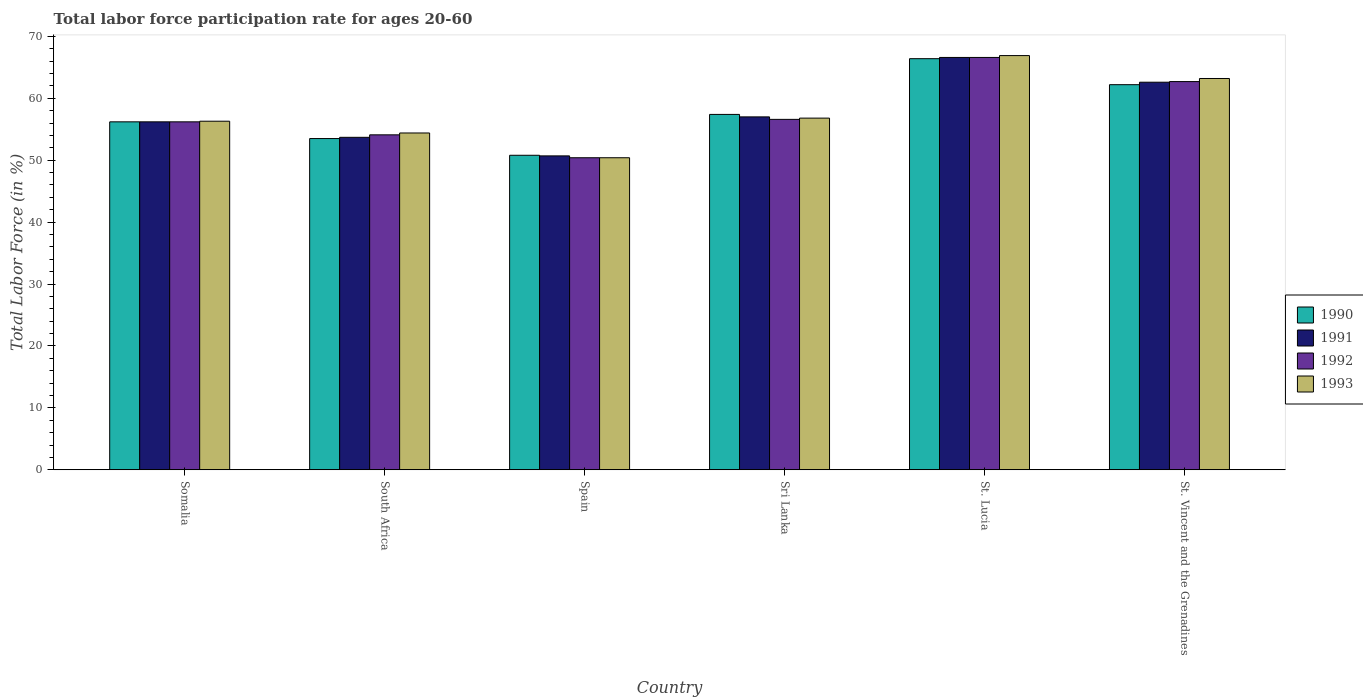Are the number of bars on each tick of the X-axis equal?
Ensure brevity in your answer.  Yes. How many bars are there on the 5th tick from the left?
Make the answer very short. 4. How many bars are there on the 1st tick from the right?
Offer a terse response. 4. What is the label of the 5th group of bars from the left?
Give a very brief answer. St. Lucia. In how many cases, is the number of bars for a given country not equal to the number of legend labels?
Ensure brevity in your answer.  0. What is the labor force participation rate in 1992 in Somalia?
Provide a succinct answer. 56.2. Across all countries, what is the maximum labor force participation rate in 1992?
Your response must be concise. 66.6. Across all countries, what is the minimum labor force participation rate in 1991?
Offer a very short reply. 50.7. In which country was the labor force participation rate in 1991 maximum?
Your answer should be very brief. St. Lucia. What is the total labor force participation rate in 1993 in the graph?
Your answer should be compact. 348. What is the difference between the labor force participation rate in 1992 in Somalia and that in St. Vincent and the Grenadines?
Offer a very short reply. -6.5. What is the difference between the labor force participation rate in 1993 in St. Lucia and the labor force participation rate in 1991 in Spain?
Make the answer very short. 16.2. What is the average labor force participation rate in 1993 per country?
Ensure brevity in your answer.  58. What is the difference between the labor force participation rate of/in 1990 and labor force participation rate of/in 1991 in Spain?
Provide a succinct answer. 0.1. What is the ratio of the labor force participation rate in 1990 in South Africa to that in St. Lucia?
Your answer should be very brief. 0.81. Is the labor force participation rate in 1992 in Sri Lanka less than that in St. Vincent and the Grenadines?
Offer a terse response. Yes. What is the difference between the highest and the second highest labor force participation rate in 1992?
Ensure brevity in your answer.  -10. What is the difference between the highest and the lowest labor force participation rate in 1991?
Your answer should be very brief. 15.9. In how many countries, is the labor force participation rate in 1991 greater than the average labor force participation rate in 1991 taken over all countries?
Provide a succinct answer. 2. What does the 4th bar from the right in Somalia represents?
Your response must be concise. 1990. Is it the case that in every country, the sum of the labor force participation rate in 1990 and labor force participation rate in 1991 is greater than the labor force participation rate in 1993?
Ensure brevity in your answer.  Yes. How many bars are there?
Ensure brevity in your answer.  24. Are the values on the major ticks of Y-axis written in scientific E-notation?
Give a very brief answer. No. Does the graph contain any zero values?
Ensure brevity in your answer.  No. How are the legend labels stacked?
Make the answer very short. Vertical. What is the title of the graph?
Your answer should be compact. Total labor force participation rate for ages 20-60. Does "2010" appear as one of the legend labels in the graph?
Offer a terse response. No. What is the label or title of the X-axis?
Ensure brevity in your answer.  Country. What is the Total Labor Force (in %) of 1990 in Somalia?
Provide a short and direct response. 56.2. What is the Total Labor Force (in %) in 1991 in Somalia?
Ensure brevity in your answer.  56.2. What is the Total Labor Force (in %) of 1992 in Somalia?
Your response must be concise. 56.2. What is the Total Labor Force (in %) in 1993 in Somalia?
Provide a short and direct response. 56.3. What is the Total Labor Force (in %) of 1990 in South Africa?
Offer a terse response. 53.5. What is the Total Labor Force (in %) in 1991 in South Africa?
Offer a very short reply. 53.7. What is the Total Labor Force (in %) in 1992 in South Africa?
Your answer should be compact. 54.1. What is the Total Labor Force (in %) of 1993 in South Africa?
Your response must be concise. 54.4. What is the Total Labor Force (in %) of 1990 in Spain?
Ensure brevity in your answer.  50.8. What is the Total Labor Force (in %) in 1991 in Spain?
Your answer should be very brief. 50.7. What is the Total Labor Force (in %) in 1992 in Spain?
Provide a succinct answer. 50.4. What is the Total Labor Force (in %) of 1993 in Spain?
Make the answer very short. 50.4. What is the Total Labor Force (in %) in 1990 in Sri Lanka?
Your response must be concise. 57.4. What is the Total Labor Force (in %) of 1991 in Sri Lanka?
Your response must be concise. 57. What is the Total Labor Force (in %) in 1992 in Sri Lanka?
Give a very brief answer. 56.6. What is the Total Labor Force (in %) of 1993 in Sri Lanka?
Offer a terse response. 56.8. What is the Total Labor Force (in %) of 1990 in St. Lucia?
Provide a succinct answer. 66.4. What is the Total Labor Force (in %) in 1991 in St. Lucia?
Offer a very short reply. 66.6. What is the Total Labor Force (in %) of 1992 in St. Lucia?
Keep it short and to the point. 66.6. What is the Total Labor Force (in %) in 1993 in St. Lucia?
Keep it short and to the point. 66.9. What is the Total Labor Force (in %) in 1990 in St. Vincent and the Grenadines?
Make the answer very short. 62.2. What is the Total Labor Force (in %) of 1991 in St. Vincent and the Grenadines?
Offer a very short reply. 62.6. What is the Total Labor Force (in %) in 1992 in St. Vincent and the Grenadines?
Your answer should be compact. 62.7. What is the Total Labor Force (in %) in 1993 in St. Vincent and the Grenadines?
Your response must be concise. 63.2. Across all countries, what is the maximum Total Labor Force (in %) of 1990?
Make the answer very short. 66.4. Across all countries, what is the maximum Total Labor Force (in %) in 1991?
Provide a succinct answer. 66.6. Across all countries, what is the maximum Total Labor Force (in %) in 1992?
Offer a very short reply. 66.6. Across all countries, what is the maximum Total Labor Force (in %) of 1993?
Your answer should be compact. 66.9. Across all countries, what is the minimum Total Labor Force (in %) of 1990?
Offer a terse response. 50.8. Across all countries, what is the minimum Total Labor Force (in %) in 1991?
Make the answer very short. 50.7. Across all countries, what is the minimum Total Labor Force (in %) in 1992?
Your response must be concise. 50.4. Across all countries, what is the minimum Total Labor Force (in %) in 1993?
Provide a succinct answer. 50.4. What is the total Total Labor Force (in %) in 1990 in the graph?
Your answer should be very brief. 346.5. What is the total Total Labor Force (in %) in 1991 in the graph?
Ensure brevity in your answer.  346.8. What is the total Total Labor Force (in %) in 1992 in the graph?
Your answer should be very brief. 346.6. What is the total Total Labor Force (in %) in 1993 in the graph?
Give a very brief answer. 348. What is the difference between the Total Labor Force (in %) of 1993 in Somalia and that in South Africa?
Your answer should be compact. 1.9. What is the difference between the Total Labor Force (in %) in 1990 in Somalia and that in Spain?
Provide a succinct answer. 5.4. What is the difference between the Total Labor Force (in %) of 1991 in Somalia and that in Spain?
Offer a terse response. 5.5. What is the difference between the Total Labor Force (in %) in 1992 in Somalia and that in Spain?
Your response must be concise. 5.8. What is the difference between the Total Labor Force (in %) of 1990 in Somalia and that in Sri Lanka?
Your answer should be compact. -1.2. What is the difference between the Total Labor Force (in %) in 1991 in Somalia and that in Sri Lanka?
Give a very brief answer. -0.8. What is the difference between the Total Labor Force (in %) of 1990 in Somalia and that in St. Lucia?
Your answer should be compact. -10.2. What is the difference between the Total Labor Force (in %) in 1993 in Somalia and that in St. Lucia?
Ensure brevity in your answer.  -10.6. What is the difference between the Total Labor Force (in %) of 1990 in Somalia and that in St. Vincent and the Grenadines?
Give a very brief answer. -6. What is the difference between the Total Labor Force (in %) in 1992 in Somalia and that in St. Vincent and the Grenadines?
Provide a succinct answer. -6.5. What is the difference between the Total Labor Force (in %) in 1993 in Somalia and that in St. Vincent and the Grenadines?
Offer a terse response. -6.9. What is the difference between the Total Labor Force (in %) of 1990 in South Africa and that in Sri Lanka?
Make the answer very short. -3.9. What is the difference between the Total Labor Force (in %) of 1991 in South Africa and that in Sri Lanka?
Make the answer very short. -3.3. What is the difference between the Total Labor Force (in %) in 1992 in South Africa and that in Sri Lanka?
Your answer should be very brief. -2.5. What is the difference between the Total Labor Force (in %) in 1990 in South Africa and that in St. Lucia?
Ensure brevity in your answer.  -12.9. What is the difference between the Total Labor Force (in %) of 1993 in South Africa and that in St. Lucia?
Provide a succinct answer. -12.5. What is the difference between the Total Labor Force (in %) in 1990 in South Africa and that in St. Vincent and the Grenadines?
Make the answer very short. -8.7. What is the difference between the Total Labor Force (in %) in 1991 in South Africa and that in St. Vincent and the Grenadines?
Your answer should be compact. -8.9. What is the difference between the Total Labor Force (in %) of 1992 in South Africa and that in St. Vincent and the Grenadines?
Your response must be concise. -8.6. What is the difference between the Total Labor Force (in %) in 1993 in South Africa and that in St. Vincent and the Grenadines?
Make the answer very short. -8.8. What is the difference between the Total Labor Force (in %) in 1990 in Spain and that in St. Lucia?
Ensure brevity in your answer.  -15.6. What is the difference between the Total Labor Force (in %) in 1991 in Spain and that in St. Lucia?
Your response must be concise. -15.9. What is the difference between the Total Labor Force (in %) of 1992 in Spain and that in St. Lucia?
Offer a terse response. -16.2. What is the difference between the Total Labor Force (in %) in 1993 in Spain and that in St. Lucia?
Your answer should be very brief. -16.5. What is the difference between the Total Labor Force (in %) of 1993 in Spain and that in St. Vincent and the Grenadines?
Provide a short and direct response. -12.8. What is the difference between the Total Labor Force (in %) in 1990 in Sri Lanka and that in St. Lucia?
Your response must be concise. -9. What is the difference between the Total Labor Force (in %) in 1991 in Sri Lanka and that in St. Vincent and the Grenadines?
Provide a short and direct response. -5.6. What is the difference between the Total Labor Force (in %) in 1990 in St. Lucia and that in St. Vincent and the Grenadines?
Make the answer very short. 4.2. What is the difference between the Total Labor Force (in %) of 1992 in St. Lucia and that in St. Vincent and the Grenadines?
Your answer should be very brief. 3.9. What is the difference between the Total Labor Force (in %) in 1993 in St. Lucia and that in St. Vincent and the Grenadines?
Offer a very short reply. 3.7. What is the difference between the Total Labor Force (in %) in 1990 in Somalia and the Total Labor Force (in %) in 1992 in South Africa?
Make the answer very short. 2.1. What is the difference between the Total Labor Force (in %) in 1990 in Somalia and the Total Labor Force (in %) in 1993 in South Africa?
Make the answer very short. 1.8. What is the difference between the Total Labor Force (in %) in 1990 in Somalia and the Total Labor Force (in %) in 1991 in Spain?
Ensure brevity in your answer.  5.5. What is the difference between the Total Labor Force (in %) in 1990 in Somalia and the Total Labor Force (in %) in 1992 in Spain?
Offer a very short reply. 5.8. What is the difference between the Total Labor Force (in %) of 1991 in Somalia and the Total Labor Force (in %) of 1992 in Spain?
Provide a short and direct response. 5.8. What is the difference between the Total Labor Force (in %) in 1990 in Somalia and the Total Labor Force (in %) in 1992 in Sri Lanka?
Provide a succinct answer. -0.4. What is the difference between the Total Labor Force (in %) in 1990 in Somalia and the Total Labor Force (in %) in 1993 in Sri Lanka?
Your answer should be very brief. -0.6. What is the difference between the Total Labor Force (in %) in 1990 in Somalia and the Total Labor Force (in %) in 1992 in St. Lucia?
Offer a terse response. -10.4. What is the difference between the Total Labor Force (in %) of 1991 in Somalia and the Total Labor Force (in %) of 1993 in St. Lucia?
Your response must be concise. -10.7. What is the difference between the Total Labor Force (in %) in 1990 in Somalia and the Total Labor Force (in %) in 1992 in St. Vincent and the Grenadines?
Your answer should be compact. -6.5. What is the difference between the Total Labor Force (in %) in 1990 in Somalia and the Total Labor Force (in %) in 1993 in St. Vincent and the Grenadines?
Your answer should be compact. -7. What is the difference between the Total Labor Force (in %) in 1992 in Somalia and the Total Labor Force (in %) in 1993 in St. Vincent and the Grenadines?
Your response must be concise. -7. What is the difference between the Total Labor Force (in %) of 1990 in South Africa and the Total Labor Force (in %) of 1991 in Spain?
Offer a very short reply. 2.8. What is the difference between the Total Labor Force (in %) in 1990 in South Africa and the Total Labor Force (in %) in 1992 in Spain?
Ensure brevity in your answer.  3.1. What is the difference between the Total Labor Force (in %) of 1991 in South Africa and the Total Labor Force (in %) of 1992 in Spain?
Provide a short and direct response. 3.3. What is the difference between the Total Labor Force (in %) of 1991 in South Africa and the Total Labor Force (in %) of 1993 in Spain?
Make the answer very short. 3.3. What is the difference between the Total Labor Force (in %) in 1992 in South Africa and the Total Labor Force (in %) in 1993 in Spain?
Offer a terse response. 3.7. What is the difference between the Total Labor Force (in %) of 1990 in South Africa and the Total Labor Force (in %) of 1993 in Sri Lanka?
Provide a succinct answer. -3.3. What is the difference between the Total Labor Force (in %) of 1992 in South Africa and the Total Labor Force (in %) of 1993 in Sri Lanka?
Provide a succinct answer. -2.7. What is the difference between the Total Labor Force (in %) in 1990 in South Africa and the Total Labor Force (in %) in 1991 in St. Lucia?
Your answer should be very brief. -13.1. What is the difference between the Total Labor Force (in %) of 1990 in South Africa and the Total Labor Force (in %) of 1992 in St. Lucia?
Give a very brief answer. -13.1. What is the difference between the Total Labor Force (in %) in 1990 in South Africa and the Total Labor Force (in %) in 1993 in St. Lucia?
Provide a succinct answer. -13.4. What is the difference between the Total Labor Force (in %) in 1992 in South Africa and the Total Labor Force (in %) in 1993 in St. Lucia?
Make the answer very short. -12.8. What is the difference between the Total Labor Force (in %) in 1990 in South Africa and the Total Labor Force (in %) in 1992 in St. Vincent and the Grenadines?
Make the answer very short. -9.2. What is the difference between the Total Labor Force (in %) in 1990 in Spain and the Total Labor Force (in %) in 1991 in Sri Lanka?
Ensure brevity in your answer.  -6.2. What is the difference between the Total Labor Force (in %) in 1991 in Spain and the Total Labor Force (in %) in 1992 in Sri Lanka?
Your response must be concise. -5.9. What is the difference between the Total Labor Force (in %) in 1990 in Spain and the Total Labor Force (in %) in 1991 in St. Lucia?
Offer a very short reply. -15.8. What is the difference between the Total Labor Force (in %) of 1990 in Spain and the Total Labor Force (in %) of 1992 in St. Lucia?
Your response must be concise. -15.8. What is the difference between the Total Labor Force (in %) of 1990 in Spain and the Total Labor Force (in %) of 1993 in St. Lucia?
Your response must be concise. -16.1. What is the difference between the Total Labor Force (in %) of 1991 in Spain and the Total Labor Force (in %) of 1992 in St. Lucia?
Provide a short and direct response. -15.9. What is the difference between the Total Labor Force (in %) in 1991 in Spain and the Total Labor Force (in %) in 1993 in St. Lucia?
Offer a terse response. -16.2. What is the difference between the Total Labor Force (in %) in 1992 in Spain and the Total Labor Force (in %) in 1993 in St. Lucia?
Offer a very short reply. -16.5. What is the difference between the Total Labor Force (in %) of 1992 in Spain and the Total Labor Force (in %) of 1993 in St. Vincent and the Grenadines?
Offer a terse response. -12.8. What is the difference between the Total Labor Force (in %) in 1990 in Sri Lanka and the Total Labor Force (in %) in 1991 in St. Lucia?
Your answer should be compact. -9.2. What is the difference between the Total Labor Force (in %) in 1990 in Sri Lanka and the Total Labor Force (in %) in 1992 in St. Lucia?
Your answer should be compact. -9.2. What is the difference between the Total Labor Force (in %) of 1991 in Sri Lanka and the Total Labor Force (in %) of 1992 in St. Lucia?
Your answer should be compact. -9.6. What is the difference between the Total Labor Force (in %) in 1991 in Sri Lanka and the Total Labor Force (in %) in 1993 in St. Lucia?
Offer a very short reply. -9.9. What is the difference between the Total Labor Force (in %) in 1992 in Sri Lanka and the Total Labor Force (in %) in 1993 in St. Lucia?
Make the answer very short. -10.3. What is the difference between the Total Labor Force (in %) of 1990 in Sri Lanka and the Total Labor Force (in %) of 1991 in St. Vincent and the Grenadines?
Your response must be concise. -5.2. What is the difference between the Total Labor Force (in %) of 1991 in Sri Lanka and the Total Labor Force (in %) of 1992 in St. Vincent and the Grenadines?
Offer a very short reply. -5.7. What is the difference between the Total Labor Force (in %) in 1990 in St. Lucia and the Total Labor Force (in %) in 1993 in St. Vincent and the Grenadines?
Provide a short and direct response. 3.2. What is the difference between the Total Labor Force (in %) in 1991 in St. Lucia and the Total Labor Force (in %) in 1993 in St. Vincent and the Grenadines?
Give a very brief answer. 3.4. What is the average Total Labor Force (in %) in 1990 per country?
Your answer should be very brief. 57.75. What is the average Total Labor Force (in %) in 1991 per country?
Provide a short and direct response. 57.8. What is the average Total Labor Force (in %) in 1992 per country?
Your answer should be compact. 57.77. What is the average Total Labor Force (in %) of 1993 per country?
Provide a succinct answer. 58. What is the difference between the Total Labor Force (in %) of 1990 and Total Labor Force (in %) of 1991 in Somalia?
Provide a succinct answer. 0. What is the difference between the Total Labor Force (in %) in 1990 and Total Labor Force (in %) in 1992 in Somalia?
Offer a terse response. 0. What is the difference between the Total Labor Force (in %) of 1990 and Total Labor Force (in %) of 1993 in Somalia?
Keep it short and to the point. -0.1. What is the difference between the Total Labor Force (in %) in 1991 and Total Labor Force (in %) in 1992 in Somalia?
Offer a terse response. 0. What is the difference between the Total Labor Force (in %) in 1991 and Total Labor Force (in %) in 1992 in South Africa?
Provide a succinct answer. -0.4. What is the difference between the Total Labor Force (in %) of 1992 and Total Labor Force (in %) of 1993 in South Africa?
Ensure brevity in your answer.  -0.3. What is the difference between the Total Labor Force (in %) of 1990 and Total Labor Force (in %) of 1991 in Spain?
Your response must be concise. 0.1. What is the difference between the Total Labor Force (in %) of 1990 and Total Labor Force (in %) of 1992 in Spain?
Your answer should be compact. 0.4. What is the difference between the Total Labor Force (in %) in 1990 and Total Labor Force (in %) in 1993 in Spain?
Ensure brevity in your answer.  0.4. What is the difference between the Total Labor Force (in %) in 1991 and Total Labor Force (in %) in 1993 in Spain?
Offer a terse response. 0.3. What is the difference between the Total Labor Force (in %) in 1990 and Total Labor Force (in %) in 1991 in Sri Lanka?
Keep it short and to the point. 0.4. What is the difference between the Total Labor Force (in %) of 1990 and Total Labor Force (in %) of 1993 in Sri Lanka?
Provide a short and direct response. 0.6. What is the difference between the Total Labor Force (in %) in 1991 and Total Labor Force (in %) in 1993 in Sri Lanka?
Your answer should be compact. 0.2. What is the difference between the Total Labor Force (in %) of 1990 and Total Labor Force (in %) of 1992 in St. Lucia?
Provide a short and direct response. -0.2. What is the difference between the Total Labor Force (in %) in 1991 and Total Labor Force (in %) in 1992 in St. Lucia?
Provide a short and direct response. 0. What is the difference between the Total Labor Force (in %) in 1991 and Total Labor Force (in %) in 1993 in St. Lucia?
Make the answer very short. -0.3. What is the difference between the Total Labor Force (in %) of 1992 and Total Labor Force (in %) of 1993 in St. Lucia?
Offer a terse response. -0.3. What is the difference between the Total Labor Force (in %) of 1990 and Total Labor Force (in %) of 1992 in St. Vincent and the Grenadines?
Offer a very short reply. -0.5. What is the difference between the Total Labor Force (in %) of 1990 and Total Labor Force (in %) of 1993 in St. Vincent and the Grenadines?
Provide a short and direct response. -1. What is the difference between the Total Labor Force (in %) of 1991 and Total Labor Force (in %) of 1992 in St. Vincent and the Grenadines?
Provide a succinct answer. -0.1. What is the difference between the Total Labor Force (in %) of 1992 and Total Labor Force (in %) of 1993 in St. Vincent and the Grenadines?
Offer a terse response. -0.5. What is the ratio of the Total Labor Force (in %) of 1990 in Somalia to that in South Africa?
Your response must be concise. 1.05. What is the ratio of the Total Labor Force (in %) in 1991 in Somalia to that in South Africa?
Ensure brevity in your answer.  1.05. What is the ratio of the Total Labor Force (in %) in 1992 in Somalia to that in South Africa?
Give a very brief answer. 1.04. What is the ratio of the Total Labor Force (in %) in 1993 in Somalia to that in South Africa?
Provide a succinct answer. 1.03. What is the ratio of the Total Labor Force (in %) of 1990 in Somalia to that in Spain?
Ensure brevity in your answer.  1.11. What is the ratio of the Total Labor Force (in %) of 1991 in Somalia to that in Spain?
Offer a very short reply. 1.11. What is the ratio of the Total Labor Force (in %) of 1992 in Somalia to that in Spain?
Ensure brevity in your answer.  1.12. What is the ratio of the Total Labor Force (in %) in 1993 in Somalia to that in Spain?
Give a very brief answer. 1.12. What is the ratio of the Total Labor Force (in %) of 1990 in Somalia to that in Sri Lanka?
Ensure brevity in your answer.  0.98. What is the ratio of the Total Labor Force (in %) of 1991 in Somalia to that in Sri Lanka?
Provide a short and direct response. 0.99. What is the ratio of the Total Labor Force (in %) of 1990 in Somalia to that in St. Lucia?
Your response must be concise. 0.85. What is the ratio of the Total Labor Force (in %) in 1991 in Somalia to that in St. Lucia?
Ensure brevity in your answer.  0.84. What is the ratio of the Total Labor Force (in %) of 1992 in Somalia to that in St. Lucia?
Provide a short and direct response. 0.84. What is the ratio of the Total Labor Force (in %) in 1993 in Somalia to that in St. Lucia?
Ensure brevity in your answer.  0.84. What is the ratio of the Total Labor Force (in %) of 1990 in Somalia to that in St. Vincent and the Grenadines?
Ensure brevity in your answer.  0.9. What is the ratio of the Total Labor Force (in %) in 1991 in Somalia to that in St. Vincent and the Grenadines?
Provide a short and direct response. 0.9. What is the ratio of the Total Labor Force (in %) in 1992 in Somalia to that in St. Vincent and the Grenadines?
Your answer should be very brief. 0.9. What is the ratio of the Total Labor Force (in %) of 1993 in Somalia to that in St. Vincent and the Grenadines?
Ensure brevity in your answer.  0.89. What is the ratio of the Total Labor Force (in %) of 1990 in South Africa to that in Spain?
Your answer should be compact. 1.05. What is the ratio of the Total Labor Force (in %) in 1991 in South Africa to that in Spain?
Your response must be concise. 1.06. What is the ratio of the Total Labor Force (in %) in 1992 in South Africa to that in Spain?
Make the answer very short. 1.07. What is the ratio of the Total Labor Force (in %) in 1993 in South Africa to that in Spain?
Your answer should be compact. 1.08. What is the ratio of the Total Labor Force (in %) of 1990 in South Africa to that in Sri Lanka?
Your response must be concise. 0.93. What is the ratio of the Total Labor Force (in %) in 1991 in South Africa to that in Sri Lanka?
Offer a very short reply. 0.94. What is the ratio of the Total Labor Force (in %) of 1992 in South Africa to that in Sri Lanka?
Keep it short and to the point. 0.96. What is the ratio of the Total Labor Force (in %) in 1993 in South Africa to that in Sri Lanka?
Give a very brief answer. 0.96. What is the ratio of the Total Labor Force (in %) in 1990 in South Africa to that in St. Lucia?
Your answer should be very brief. 0.81. What is the ratio of the Total Labor Force (in %) in 1991 in South Africa to that in St. Lucia?
Offer a very short reply. 0.81. What is the ratio of the Total Labor Force (in %) of 1992 in South Africa to that in St. Lucia?
Provide a short and direct response. 0.81. What is the ratio of the Total Labor Force (in %) of 1993 in South Africa to that in St. Lucia?
Your answer should be compact. 0.81. What is the ratio of the Total Labor Force (in %) of 1990 in South Africa to that in St. Vincent and the Grenadines?
Provide a short and direct response. 0.86. What is the ratio of the Total Labor Force (in %) in 1991 in South Africa to that in St. Vincent and the Grenadines?
Give a very brief answer. 0.86. What is the ratio of the Total Labor Force (in %) of 1992 in South Africa to that in St. Vincent and the Grenadines?
Provide a succinct answer. 0.86. What is the ratio of the Total Labor Force (in %) of 1993 in South Africa to that in St. Vincent and the Grenadines?
Make the answer very short. 0.86. What is the ratio of the Total Labor Force (in %) in 1990 in Spain to that in Sri Lanka?
Make the answer very short. 0.89. What is the ratio of the Total Labor Force (in %) in 1991 in Spain to that in Sri Lanka?
Give a very brief answer. 0.89. What is the ratio of the Total Labor Force (in %) in 1992 in Spain to that in Sri Lanka?
Ensure brevity in your answer.  0.89. What is the ratio of the Total Labor Force (in %) of 1993 in Spain to that in Sri Lanka?
Keep it short and to the point. 0.89. What is the ratio of the Total Labor Force (in %) in 1990 in Spain to that in St. Lucia?
Give a very brief answer. 0.77. What is the ratio of the Total Labor Force (in %) in 1991 in Spain to that in St. Lucia?
Offer a terse response. 0.76. What is the ratio of the Total Labor Force (in %) in 1992 in Spain to that in St. Lucia?
Ensure brevity in your answer.  0.76. What is the ratio of the Total Labor Force (in %) in 1993 in Spain to that in St. Lucia?
Your answer should be compact. 0.75. What is the ratio of the Total Labor Force (in %) of 1990 in Spain to that in St. Vincent and the Grenadines?
Your response must be concise. 0.82. What is the ratio of the Total Labor Force (in %) of 1991 in Spain to that in St. Vincent and the Grenadines?
Your response must be concise. 0.81. What is the ratio of the Total Labor Force (in %) in 1992 in Spain to that in St. Vincent and the Grenadines?
Ensure brevity in your answer.  0.8. What is the ratio of the Total Labor Force (in %) of 1993 in Spain to that in St. Vincent and the Grenadines?
Your answer should be compact. 0.8. What is the ratio of the Total Labor Force (in %) in 1990 in Sri Lanka to that in St. Lucia?
Ensure brevity in your answer.  0.86. What is the ratio of the Total Labor Force (in %) of 1991 in Sri Lanka to that in St. Lucia?
Your response must be concise. 0.86. What is the ratio of the Total Labor Force (in %) in 1992 in Sri Lanka to that in St. Lucia?
Offer a very short reply. 0.85. What is the ratio of the Total Labor Force (in %) of 1993 in Sri Lanka to that in St. Lucia?
Provide a short and direct response. 0.85. What is the ratio of the Total Labor Force (in %) in 1990 in Sri Lanka to that in St. Vincent and the Grenadines?
Offer a very short reply. 0.92. What is the ratio of the Total Labor Force (in %) of 1991 in Sri Lanka to that in St. Vincent and the Grenadines?
Give a very brief answer. 0.91. What is the ratio of the Total Labor Force (in %) in 1992 in Sri Lanka to that in St. Vincent and the Grenadines?
Offer a terse response. 0.9. What is the ratio of the Total Labor Force (in %) in 1993 in Sri Lanka to that in St. Vincent and the Grenadines?
Offer a very short reply. 0.9. What is the ratio of the Total Labor Force (in %) in 1990 in St. Lucia to that in St. Vincent and the Grenadines?
Give a very brief answer. 1.07. What is the ratio of the Total Labor Force (in %) in 1991 in St. Lucia to that in St. Vincent and the Grenadines?
Offer a terse response. 1.06. What is the ratio of the Total Labor Force (in %) in 1992 in St. Lucia to that in St. Vincent and the Grenadines?
Give a very brief answer. 1.06. What is the ratio of the Total Labor Force (in %) of 1993 in St. Lucia to that in St. Vincent and the Grenadines?
Make the answer very short. 1.06. What is the difference between the highest and the second highest Total Labor Force (in %) of 1991?
Your answer should be compact. 4. What is the difference between the highest and the second highest Total Labor Force (in %) in 1992?
Give a very brief answer. 3.9. What is the difference between the highest and the second highest Total Labor Force (in %) of 1993?
Your response must be concise. 3.7. What is the difference between the highest and the lowest Total Labor Force (in %) in 1990?
Ensure brevity in your answer.  15.6. What is the difference between the highest and the lowest Total Labor Force (in %) of 1993?
Make the answer very short. 16.5. 